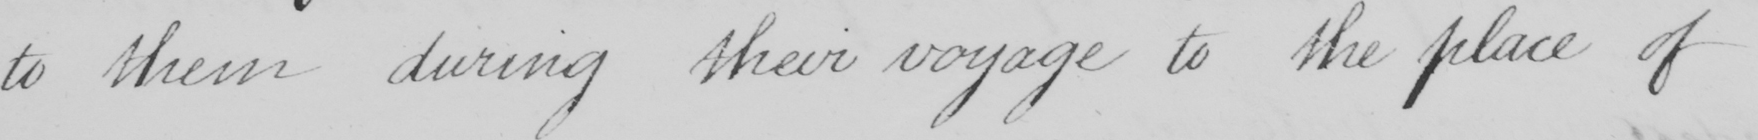What text is written in this handwritten line? to them during their voyage to the place of 